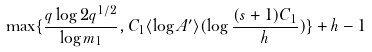Convert formula to latex. <formula><loc_0><loc_0><loc_500><loc_500>\max \{ \frac { q \log 2 q ^ { 1 / 2 } } { \log m _ { 1 } } , C _ { 1 } \langle \log A ^ { \prime } \rangle ( \log \frac { ( s + 1 ) C _ { 1 } } { h } ) \} + h - 1</formula> 